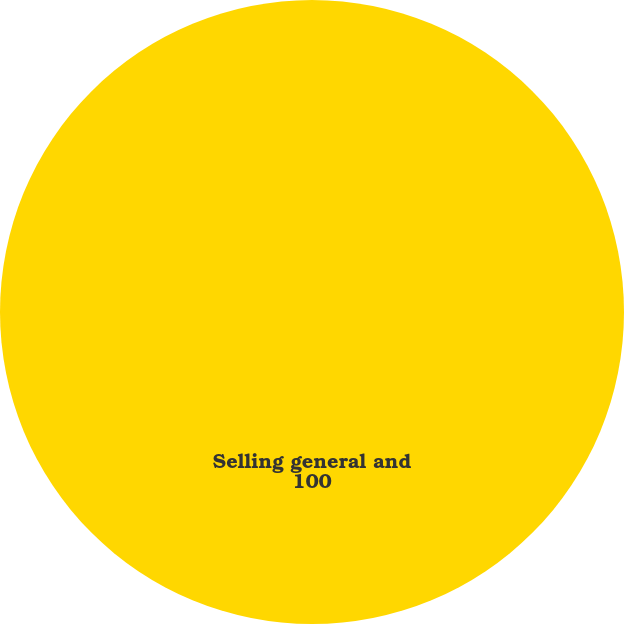<chart> <loc_0><loc_0><loc_500><loc_500><pie_chart><fcel>Selling general and<nl><fcel>100.0%<nl></chart> 